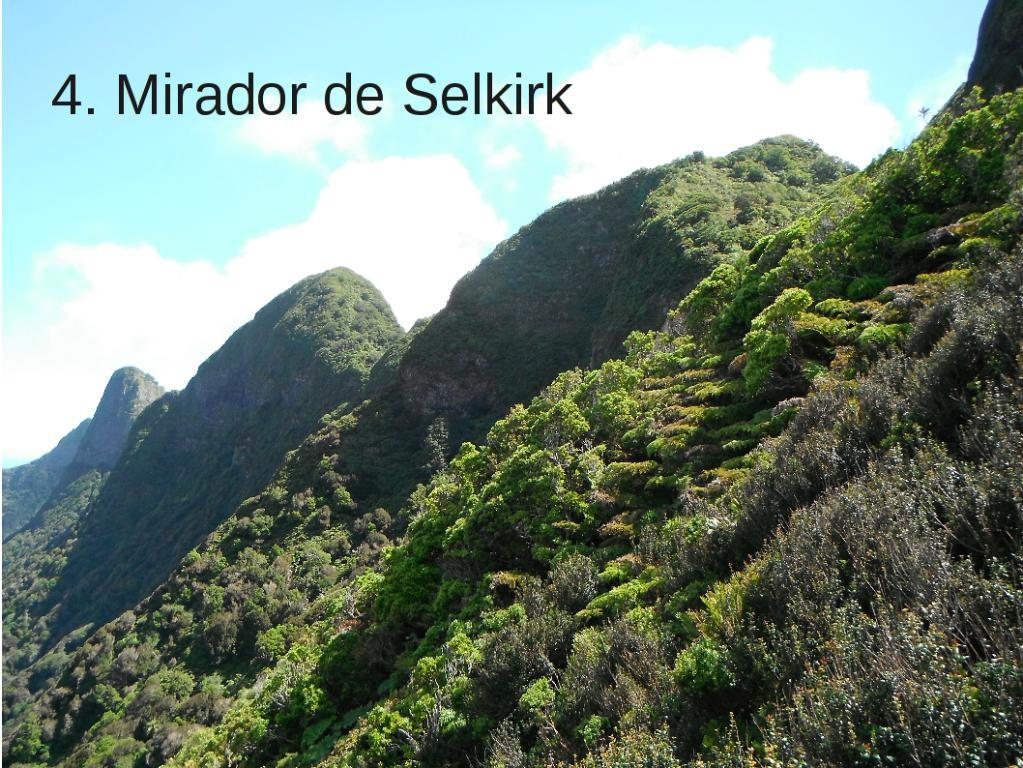What type of natural landscape is depicted in the image? The image features mountains. What type of vegetation can be seen in the image? There are green plants and trees in the image. What is visible at the top of the image? The sky is visible at the top of the image. Where is the crowd gathered in the image? There is no crowd present in the image; it features mountains, green plants, trees, and the sky. Can you see any fangs on the trees in the image? There are no fangs present on the trees in the image; it features trees with leaves or needles. 